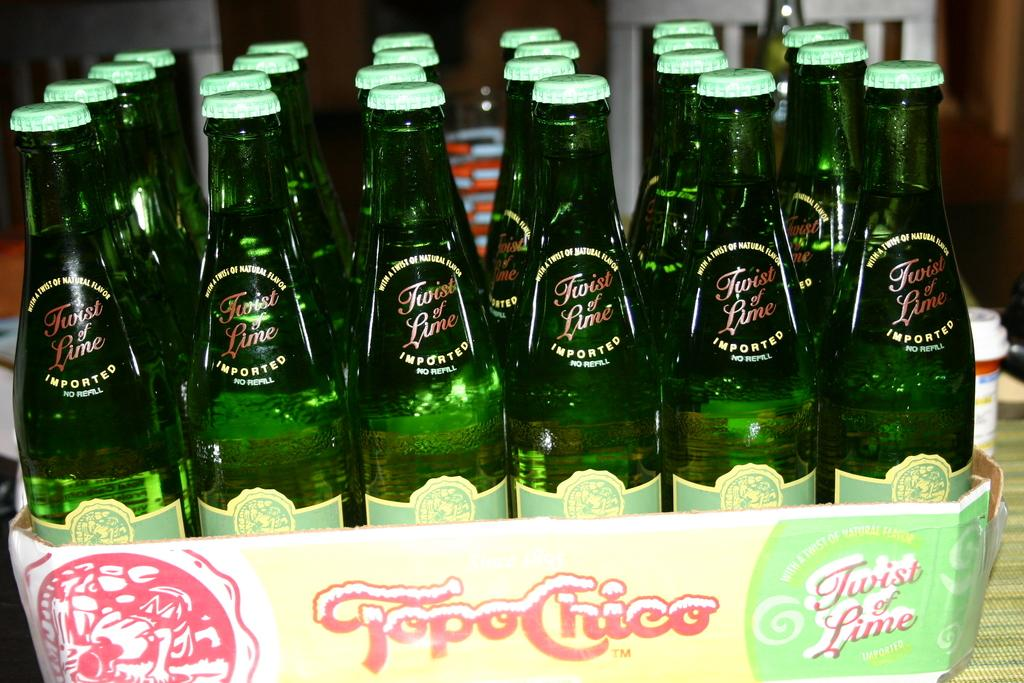Provide a one-sentence caption for the provided image. The case of Topo Chico was delivered to the restaurant. 